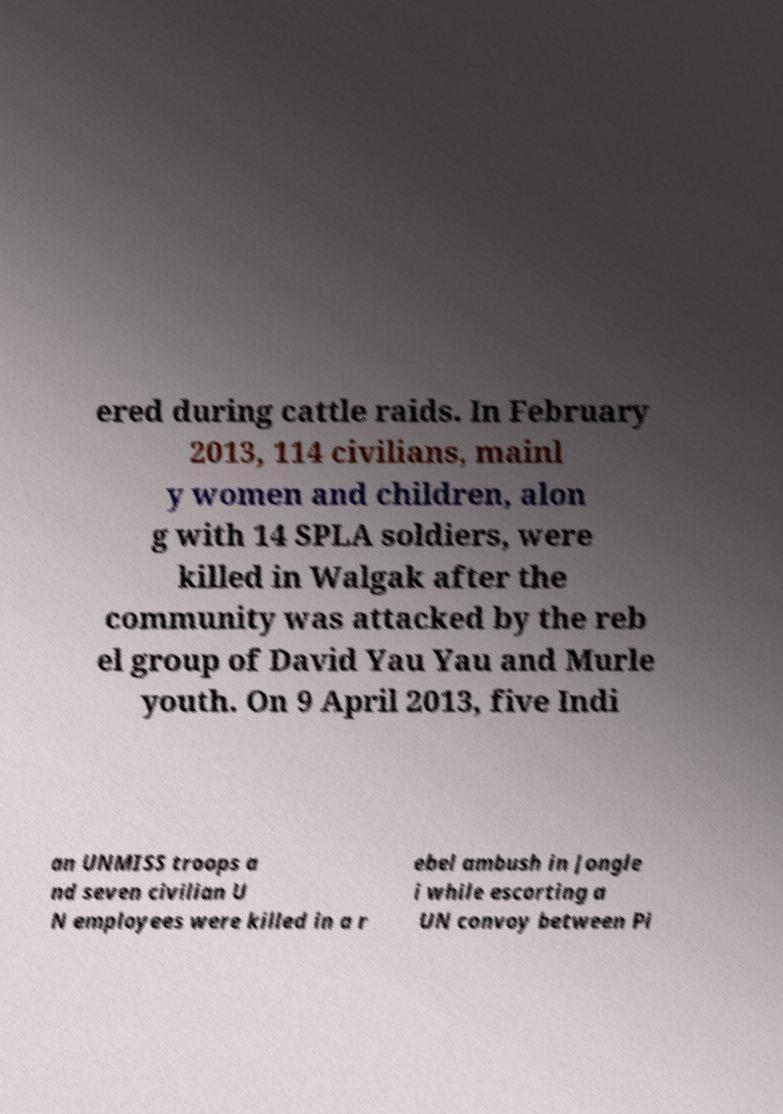What messages or text are displayed in this image? I need them in a readable, typed format. ered during cattle raids. In February 2013, 114 civilians, mainl y women and children, alon g with 14 SPLA soldiers, were killed in Walgak after the community was attacked by the reb el group of David Yau Yau and Murle youth. On 9 April 2013, five Indi an UNMISS troops a nd seven civilian U N employees were killed in a r ebel ambush in Jongle i while escorting a UN convoy between Pi 